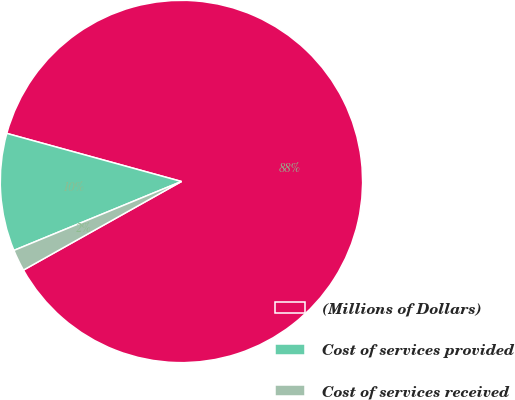Convert chart to OTSL. <chart><loc_0><loc_0><loc_500><loc_500><pie_chart><fcel>(Millions of Dollars)<fcel>Cost of services provided<fcel>Cost of services received<nl><fcel>87.59%<fcel>10.49%<fcel>1.92%<nl></chart> 